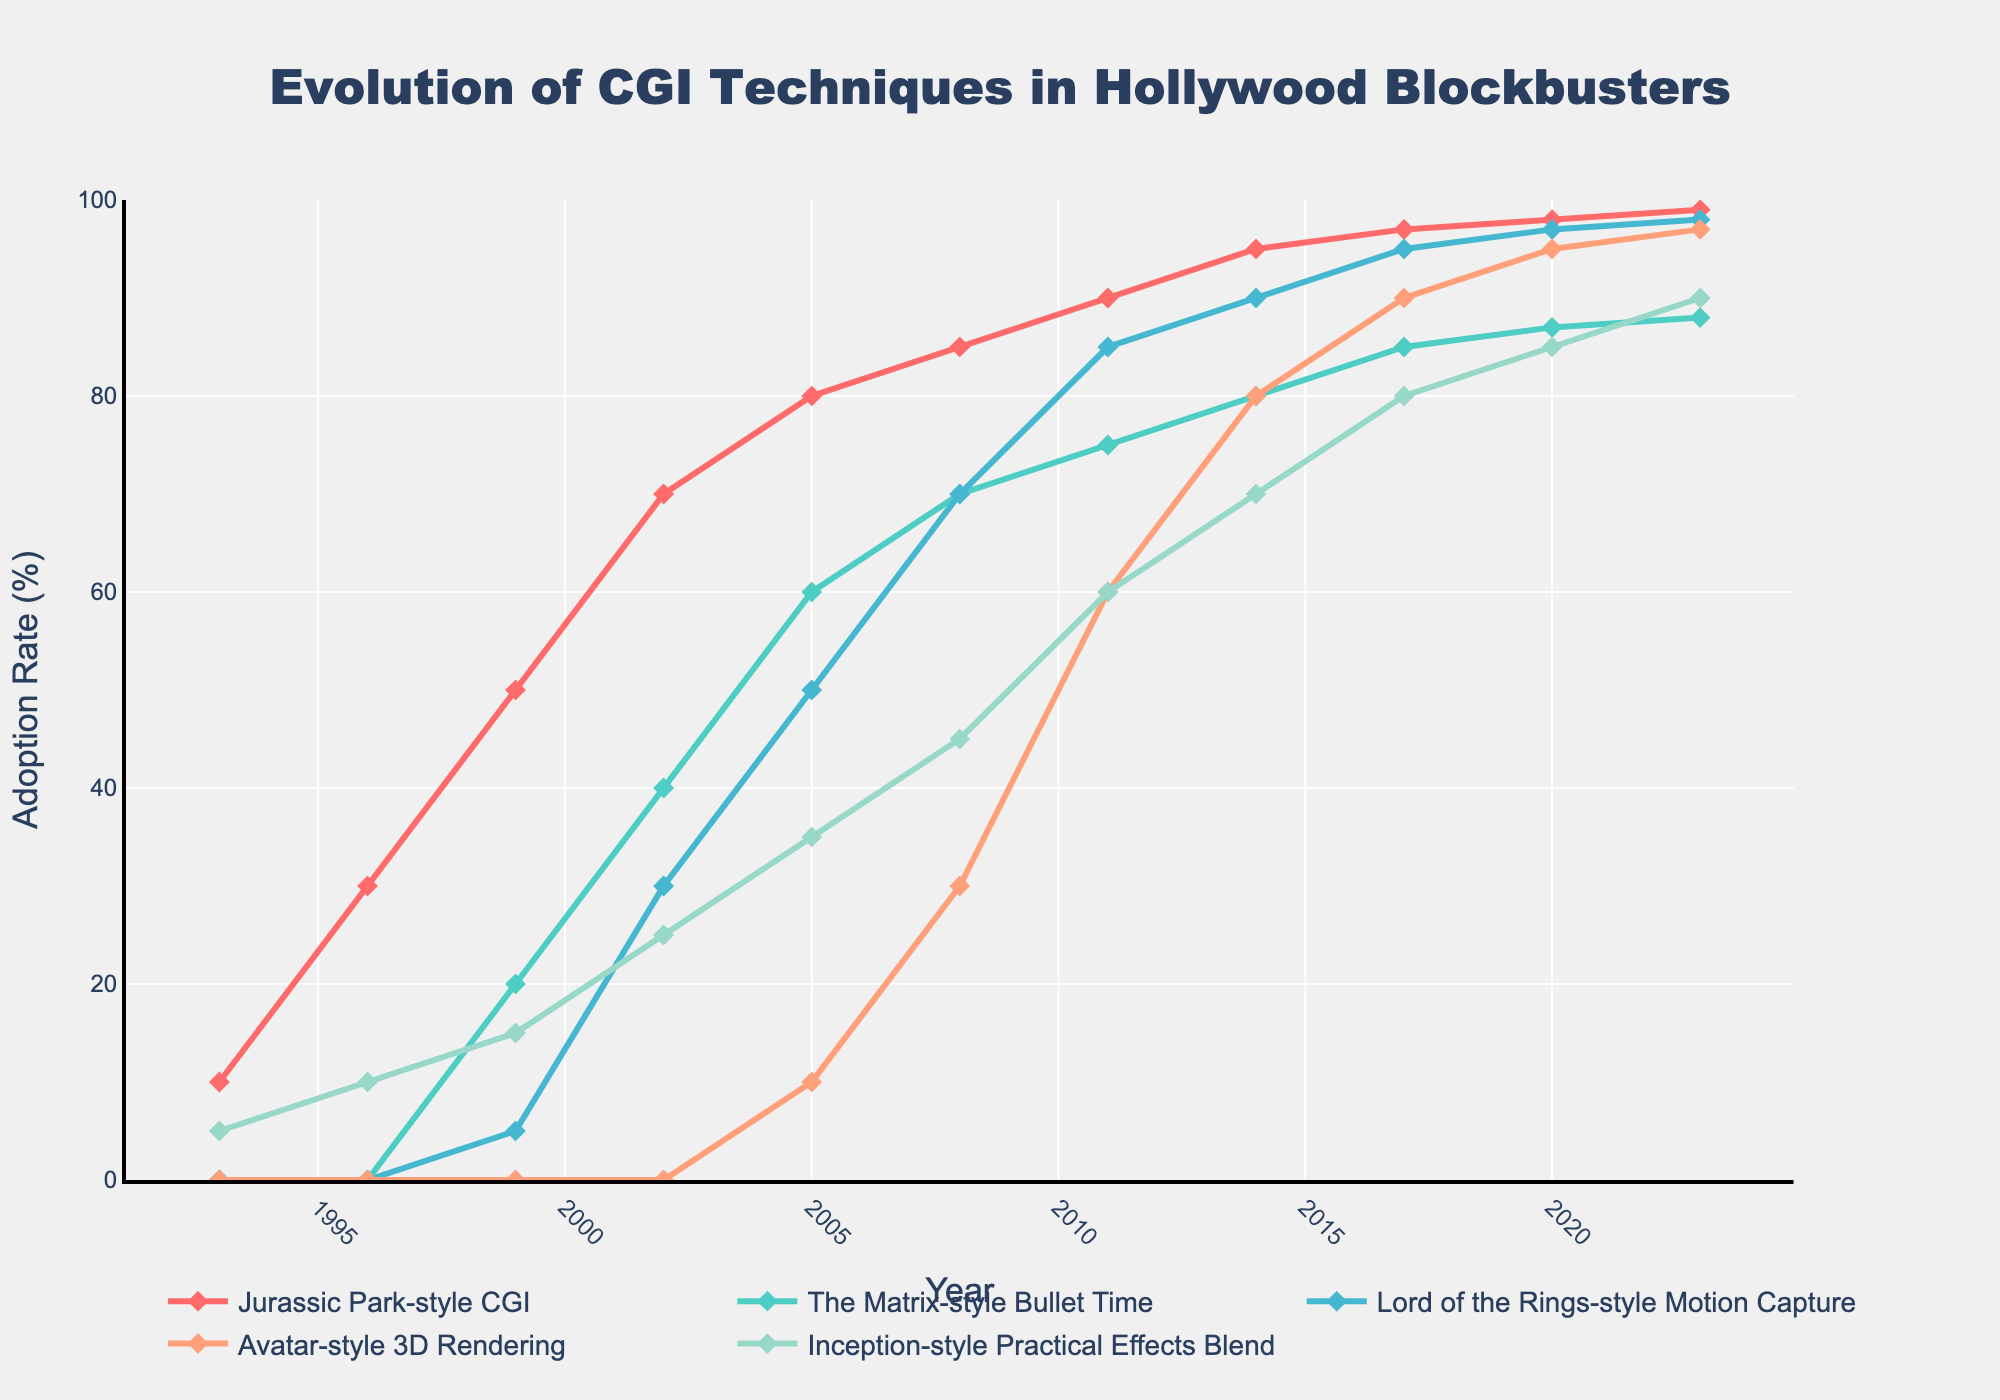what year did the Jurassic Park-style CGI technique start being widely adopted? The Jurassic Park-style CGI technique shows a notable adoption starting from 1993 as indicated by a visible increase in the line plot.
Answer: 1993 how many years after 1993 did the Avatar-style 3D Rendering start showing significant adoption? The Avatar-style 3D Rendering started showing a significant adoption in 2005. By comparing the years, 2005 - 1993 = 12 years.
Answer: 12 years which technique reached a 90% adoption rate, and in what year did it achieve this? The data indicates that the Lord of the Rings-style Motion Capture reached a 90% adoption rate, and it achieved this in the year 2014.
Answer: Lord of the Rings-style Motion Capture, 2014 how does the adoption rate of The Matrix-style Bullet Time in 2023 compare to that in 1999? In 2023, The Matrix-style Bullet Time has an adoption rate of 88%. In 1999, the adoption rate was 20%. The difference is 88% - 20% = 68%.
Answer: 88% vs. 20% what is the average adoption rate of the Inception-style Practical Effects Blend in the years 2008, 2011, and 2014? The adoption rate numbers for the given years are: 2008 (45%), 2011 (60%), and 2014 (70%). The average rate is (45 + 60 + 70) / 3 = 175 / 3 = 58.3%.
Answer: 58.3% which CGI technique has the highest adoption rate overall, and what is its adoption rate in 2023? The Jurassic Park-style CGI has the highest adoption rate overall with a rate of 99% in 2023.
Answer: Jurassic Park-style CGI, 99% what is the adoption rate difference between the highest and lowest adoption rates among all techniques in the year 2002? In 2002, the highest adoption rate is for Jurassic Park-style CGI (70%), and the lowest is for Avatar-style 3D Rendering (0%). The difference is 70% - 0% = 70%.
Answer: 70% how did the adoption of the Lord of the Rings-style Motion Capture change between 1999 and 2014? The adoption rate of the Lord of the Rings-style Motion Capture increased from 5% in 1999 to 90% in 2014. The increase is 90% - 5% = 85%.
Answer: Increased by 85% how does the adoption trend of the Inception-style Practical Effects Blend compare visually to the other CGI techniques from 1993 to 2023? Visually, the line representing Inception-style Practical Effects Blend shows a steadier and slower increase compared to other techniques, which show more rapid and steeper increases.
Answer: Steadier and slower increase in what year did all five CGI techniques first exceed a 50% adoption rate? According to the chart, all five CGI techniques first exceed a 50% adoption rate in the year 2008.
Answer: 2008 